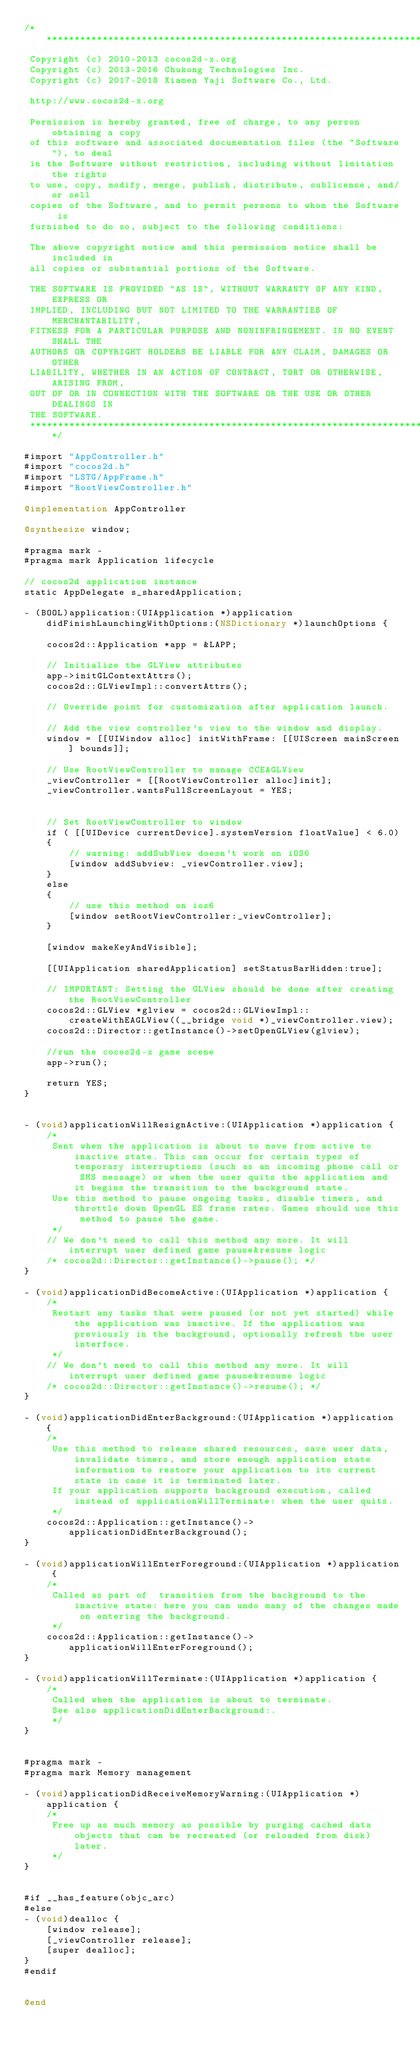<code> <loc_0><loc_0><loc_500><loc_500><_ObjectiveC_>/****************************************************************************
 Copyright (c) 2010-2013 cocos2d-x.org
 Copyright (c) 2013-2016 Chukong Technologies Inc.
 Copyright (c) 2017-2018 Xiamen Yaji Software Co., Ltd.
 
 http://www.cocos2d-x.org
 
 Permission is hereby granted, free of charge, to any person obtaining a copy
 of this software and associated documentation files (the "Software"), to deal
 in the Software without restriction, including without limitation the rights
 to use, copy, modify, merge, publish, distribute, sublicense, and/or sell
 copies of the Software, and to permit persons to whom the Software is
 furnished to do so, subject to the following conditions:
 
 The above copyright notice and this permission notice shall be included in
 all copies or substantial portions of the Software.
 
 THE SOFTWARE IS PROVIDED "AS IS", WITHOUT WARRANTY OF ANY KIND, EXPRESS OR
 IMPLIED, INCLUDING BUT NOT LIMITED TO THE WARRANTIES OF MERCHANTABILITY,
 FITNESS FOR A PARTICULAR PURPOSE AND NONINFRINGEMENT. IN NO EVENT SHALL THE
 AUTHORS OR COPYRIGHT HOLDERS BE LIABLE FOR ANY CLAIM, DAMAGES OR OTHER
 LIABILITY, WHETHER IN AN ACTION OF CONTRACT, TORT OR OTHERWISE, ARISING FROM,
 OUT OF OR IN CONNECTION WITH THE SOFTWARE OR THE USE OR OTHER DEALINGS IN
 THE SOFTWARE.
 ****************************************************************************/

#import "AppController.h"
#import "cocos2d.h"
#import "LSTG/AppFrame.h"
#import "RootViewController.h"

@implementation AppController

@synthesize window;

#pragma mark -
#pragma mark Application lifecycle

// cocos2d application instance
static AppDelegate s_sharedApplication;

- (BOOL)application:(UIApplication *)application didFinishLaunchingWithOptions:(NSDictionary *)launchOptions {
    
    cocos2d::Application *app = &LAPP;
    
    // Initialize the GLView attributes
    app->initGLContextAttrs();
    cocos2d::GLViewImpl::convertAttrs();
    
    // Override point for customization after application launch.

    // Add the view controller's view to the window and display.
    window = [[UIWindow alloc] initWithFrame: [[UIScreen mainScreen] bounds]];

    // Use RootViewController to manage CCEAGLView
    _viewController = [[RootViewController alloc]init];
    _viewController.wantsFullScreenLayout = YES;
    

    // Set RootViewController to window
    if ( [[UIDevice currentDevice].systemVersion floatValue] < 6.0)
    {
        // warning: addSubView doesn't work on iOS6
        [window addSubview: _viewController.view];
    }
    else
    {
        // use this method on ios6
        [window setRootViewController:_viewController];
    }

    [window makeKeyAndVisible];

    [[UIApplication sharedApplication] setStatusBarHidden:true];
    
    // IMPORTANT: Setting the GLView should be done after creating the RootViewController
    cocos2d::GLView *glview = cocos2d::GLViewImpl::createWithEAGLView((__bridge void *)_viewController.view);
    cocos2d::Director::getInstance()->setOpenGLView(glview);
    
    //run the cocos2d-x game scene
    app->run();

    return YES;
}


- (void)applicationWillResignActive:(UIApplication *)application {
    /*
     Sent when the application is about to move from active to inactive state. This can occur for certain types of temporary interruptions (such as an incoming phone call or SMS message) or when the user quits the application and it begins the transition to the background state.
     Use this method to pause ongoing tasks, disable timers, and throttle down OpenGL ES frame rates. Games should use this method to pause the game.
     */
    // We don't need to call this method any more. It will interrupt user defined game pause&resume logic
    /* cocos2d::Director::getInstance()->pause(); */
}

- (void)applicationDidBecomeActive:(UIApplication *)application {
    /*
     Restart any tasks that were paused (or not yet started) while the application was inactive. If the application was previously in the background, optionally refresh the user interface.
     */
    // We don't need to call this method any more. It will interrupt user defined game pause&resume logic
    /* cocos2d::Director::getInstance()->resume(); */
}

- (void)applicationDidEnterBackground:(UIApplication *)application {
    /*
     Use this method to release shared resources, save user data, invalidate timers, and store enough application state information to restore your application to its current state in case it is terminated later. 
     If your application supports background execution, called instead of applicationWillTerminate: when the user quits.
     */
    cocos2d::Application::getInstance()->applicationDidEnterBackground();
}

- (void)applicationWillEnterForeground:(UIApplication *)application {
    /*
     Called as part of  transition from the background to the inactive state: here you can undo many of the changes made on entering the background.
     */
    cocos2d::Application::getInstance()->applicationWillEnterForeground();
}

- (void)applicationWillTerminate:(UIApplication *)application {
    /*
     Called when the application is about to terminate.
     See also applicationDidEnterBackground:.
     */
}


#pragma mark -
#pragma mark Memory management

- (void)applicationDidReceiveMemoryWarning:(UIApplication *)application {
    /*
     Free up as much memory as possible by purging cached data objects that can be recreated (or reloaded from disk) later.
     */
}


#if __has_feature(objc_arc)
#else
- (void)dealloc {
    [window release];
    [_viewController release];
    [super dealloc];
}
#endif


@end
</code> 